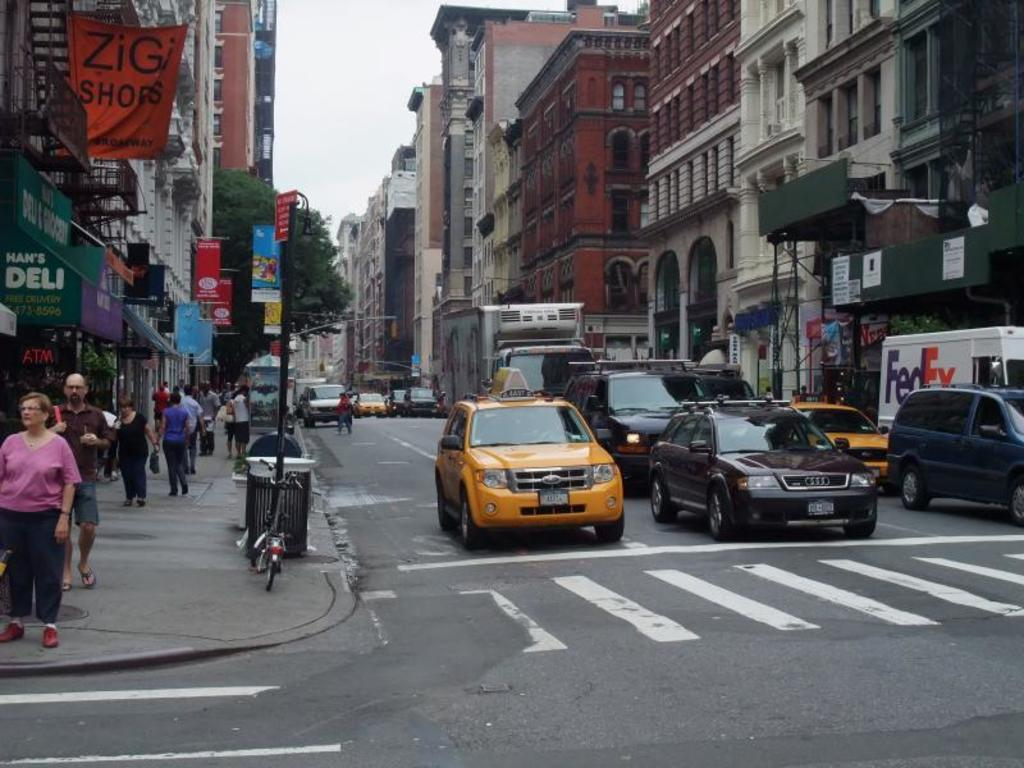Provide a one-sentence caption for the provided image. the word zig on an orange sign that is outside. 